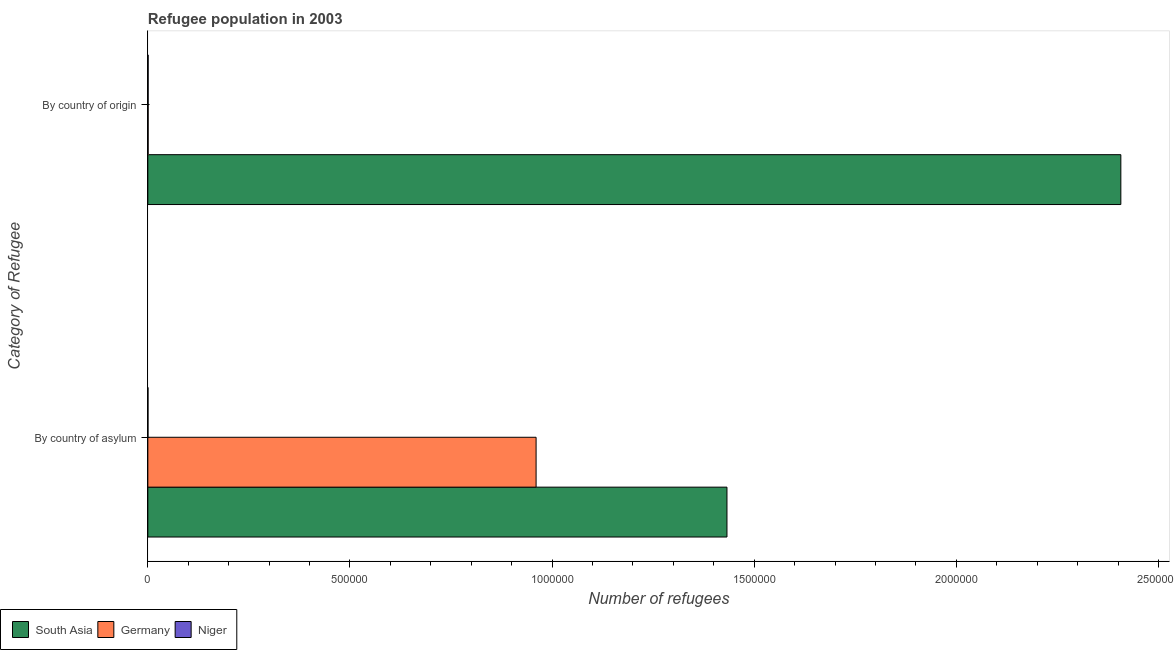How many different coloured bars are there?
Your answer should be very brief. 3. How many groups of bars are there?
Your answer should be compact. 2. Are the number of bars per tick equal to the number of legend labels?
Provide a short and direct response. Yes. How many bars are there on the 2nd tick from the bottom?
Provide a short and direct response. 3. What is the label of the 2nd group of bars from the top?
Your answer should be compact. By country of asylum. What is the number of refugees by country of asylum in Germany?
Provide a succinct answer. 9.60e+05. Across all countries, what is the maximum number of refugees by country of asylum?
Your answer should be very brief. 1.43e+06. Across all countries, what is the minimum number of refugees by country of origin?
Your answer should be compact. 725. What is the total number of refugees by country of asylum in the graph?
Keep it short and to the point. 2.39e+06. What is the difference between the number of refugees by country of asylum in Germany and that in Niger?
Offer a very short reply. 9.60e+05. What is the difference between the number of refugees by country of origin in Germany and the number of refugees by country of asylum in Niger?
Offer a very short reply. 397. What is the average number of refugees by country of asylum per country?
Keep it short and to the point. 7.98e+05. What is the difference between the number of refugees by country of asylum and number of refugees by country of origin in Niger?
Your answer should be compact. -400. In how many countries, is the number of refugees by country of asylum greater than 700000 ?
Your answer should be very brief. 2. What is the ratio of the number of refugees by country of asylum in Niger to that in Germany?
Keep it short and to the point. 0. How many countries are there in the graph?
Make the answer very short. 3. Are the values on the major ticks of X-axis written in scientific E-notation?
Offer a very short reply. No. Does the graph contain any zero values?
Give a very brief answer. No. How many legend labels are there?
Offer a very short reply. 3. What is the title of the graph?
Provide a short and direct response. Refugee population in 2003. Does "Iraq" appear as one of the legend labels in the graph?
Give a very brief answer. No. What is the label or title of the X-axis?
Ensure brevity in your answer.  Number of refugees. What is the label or title of the Y-axis?
Your answer should be compact. Category of Refugee. What is the Number of refugees of South Asia in By country of asylum?
Your answer should be very brief. 1.43e+06. What is the Number of refugees of Germany in By country of asylum?
Provide a succinct answer. 9.60e+05. What is the Number of refugees of Niger in By country of asylum?
Your response must be concise. 328. What is the Number of refugees of South Asia in By country of origin?
Your response must be concise. 2.41e+06. What is the Number of refugees in Germany in By country of origin?
Provide a succinct answer. 725. What is the Number of refugees of Niger in By country of origin?
Keep it short and to the point. 728. Across all Category of Refugee, what is the maximum Number of refugees of South Asia?
Your answer should be compact. 2.41e+06. Across all Category of Refugee, what is the maximum Number of refugees of Germany?
Offer a very short reply. 9.60e+05. Across all Category of Refugee, what is the maximum Number of refugees in Niger?
Make the answer very short. 728. Across all Category of Refugee, what is the minimum Number of refugees in South Asia?
Offer a terse response. 1.43e+06. Across all Category of Refugee, what is the minimum Number of refugees of Germany?
Offer a very short reply. 725. Across all Category of Refugee, what is the minimum Number of refugees of Niger?
Make the answer very short. 328. What is the total Number of refugees in South Asia in the graph?
Your answer should be very brief. 3.84e+06. What is the total Number of refugees in Germany in the graph?
Offer a very short reply. 9.61e+05. What is the total Number of refugees in Niger in the graph?
Ensure brevity in your answer.  1056. What is the difference between the Number of refugees in South Asia in By country of asylum and that in By country of origin?
Ensure brevity in your answer.  -9.74e+05. What is the difference between the Number of refugees of Germany in By country of asylum and that in By country of origin?
Give a very brief answer. 9.60e+05. What is the difference between the Number of refugees in Niger in By country of asylum and that in By country of origin?
Your response must be concise. -400. What is the difference between the Number of refugees of South Asia in By country of asylum and the Number of refugees of Germany in By country of origin?
Your answer should be compact. 1.43e+06. What is the difference between the Number of refugees of South Asia in By country of asylum and the Number of refugees of Niger in By country of origin?
Provide a short and direct response. 1.43e+06. What is the difference between the Number of refugees in Germany in By country of asylum and the Number of refugees in Niger in By country of origin?
Offer a terse response. 9.60e+05. What is the average Number of refugees in South Asia per Category of Refugee?
Your answer should be compact. 1.92e+06. What is the average Number of refugees in Germany per Category of Refugee?
Provide a short and direct response. 4.81e+05. What is the average Number of refugees of Niger per Category of Refugee?
Make the answer very short. 528. What is the difference between the Number of refugees in South Asia and Number of refugees in Germany in By country of asylum?
Provide a succinct answer. 4.72e+05. What is the difference between the Number of refugees of South Asia and Number of refugees of Niger in By country of asylum?
Your answer should be compact. 1.43e+06. What is the difference between the Number of refugees of Germany and Number of refugees of Niger in By country of asylum?
Offer a terse response. 9.60e+05. What is the difference between the Number of refugees of South Asia and Number of refugees of Germany in By country of origin?
Your answer should be very brief. 2.41e+06. What is the difference between the Number of refugees in South Asia and Number of refugees in Niger in By country of origin?
Offer a terse response. 2.41e+06. What is the ratio of the Number of refugees of South Asia in By country of asylum to that in By country of origin?
Offer a terse response. 0.6. What is the ratio of the Number of refugees in Germany in By country of asylum to that in By country of origin?
Keep it short and to the point. 1324.68. What is the ratio of the Number of refugees in Niger in By country of asylum to that in By country of origin?
Make the answer very short. 0.45. What is the difference between the highest and the second highest Number of refugees in South Asia?
Your response must be concise. 9.74e+05. What is the difference between the highest and the second highest Number of refugees in Germany?
Give a very brief answer. 9.60e+05. What is the difference between the highest and the lowest Number of refugees of South Asia?
Offer a very short reply. 9.74e+05. What is the difference between the highest and the lowest Number of refugees of Germany?
Ensure brevity in your answer.  9.60e+05. What is the difference between the highest and the lowest Number of refugees in Niger?
Your answer should be very brief. 400. 